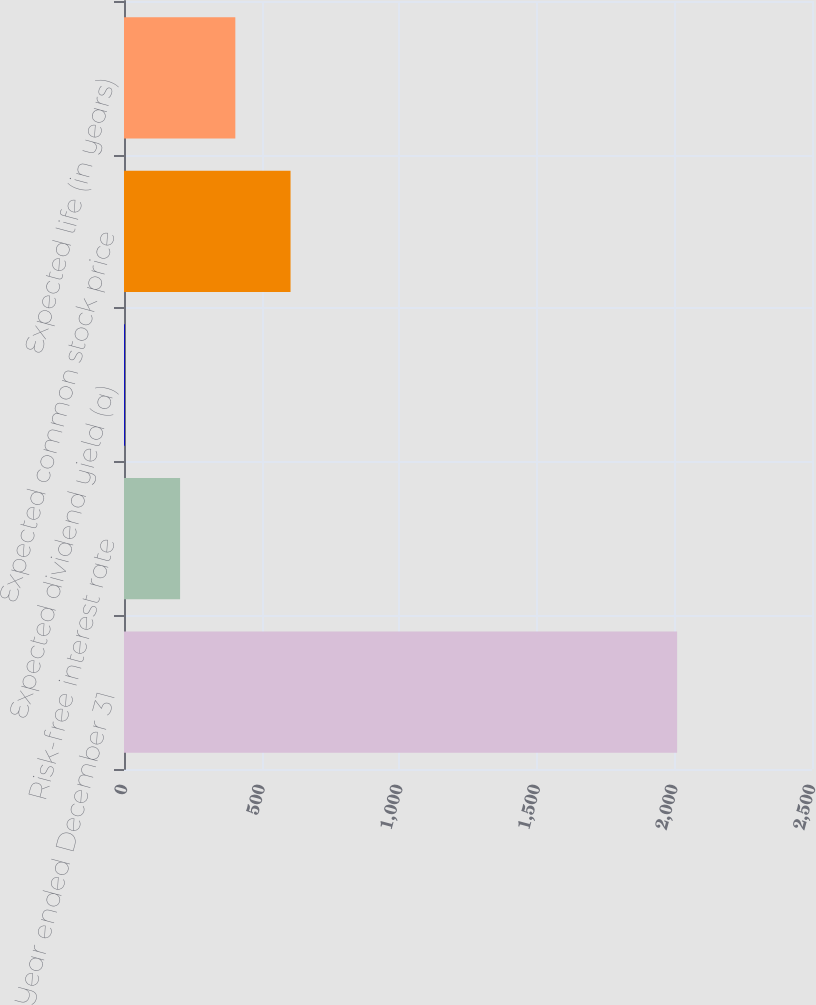Convert chart. <chart><loc_0><loc_0><loc_500><loc_500><bar_chart><fcel>Year ended December 31<fcel>Risk-free interest rate<fcel>Expected dividend yield (a)<fcel>Expected common stock price<fcel>Expected life (in years)<nl><fcel>2010<fcel>203.82<fcel>3.13<fcel>605.2<fcel>404.51<nl></chart> 